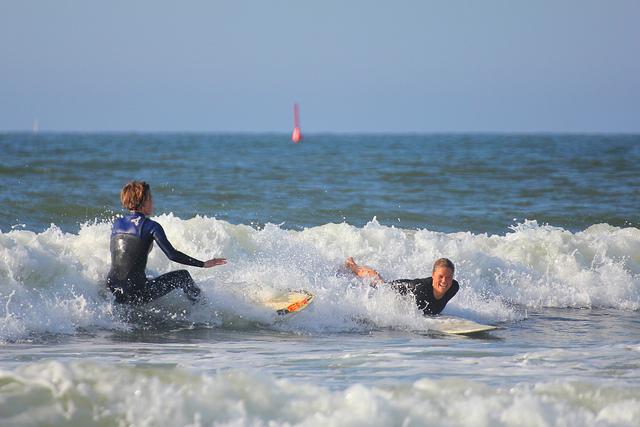Is that a woman on the left?
Give a very brief answer. Yes. Is the water rocky?
Keep it brief. No. What are the people doing?
Concise answer only. Surfing. How many people are shown?
Keep it brief. 2. 